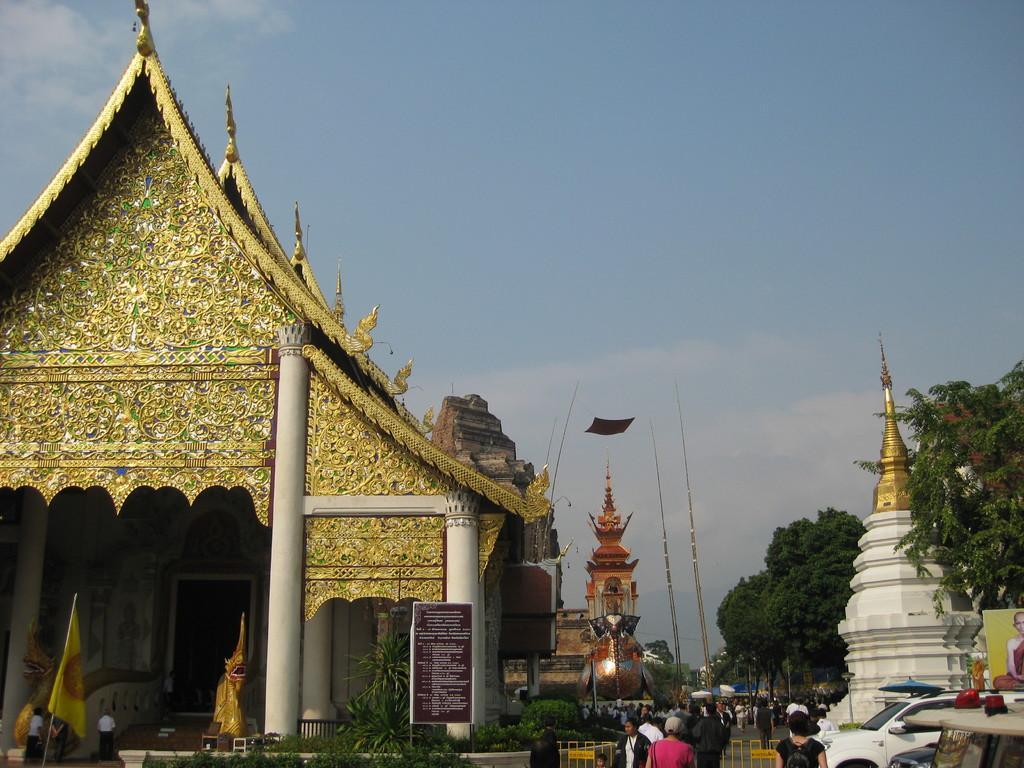Please provide a concise description of this image. In the foreground of the picture there are plants, people, vehicles and temples. In the center of the picture there are trees, people, vehicles, steeple and other objects. Sky is partially cloudy. 